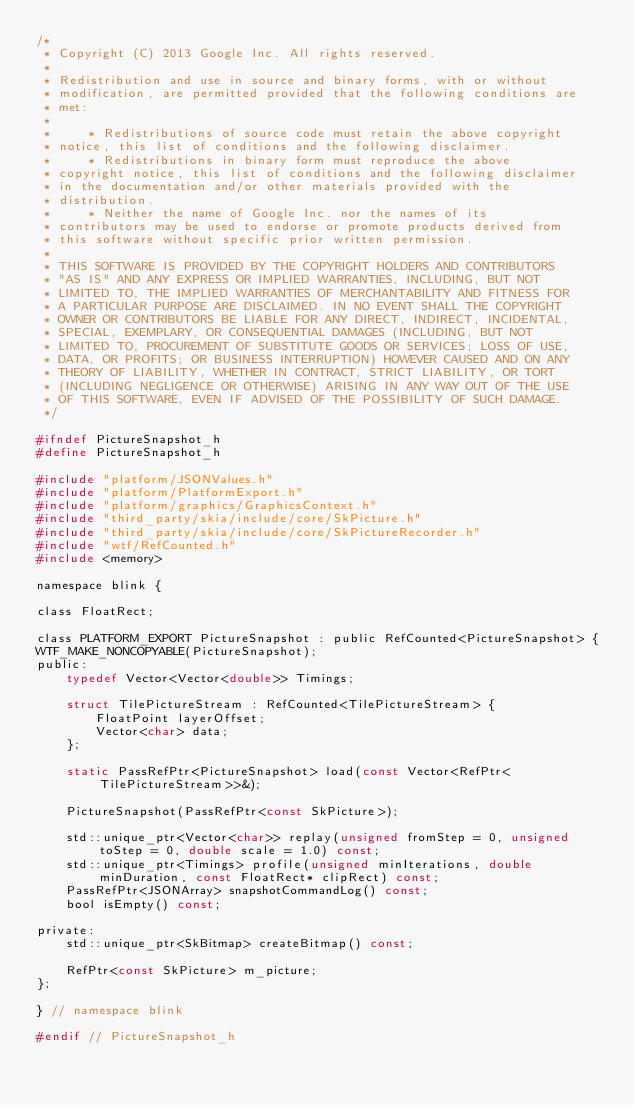Convert code to text. <code><loc_0><loc_0><loc_500><loc_500><_C_>/*
 * Copyright (C) 2013 Google Inc. All rights reserved.
 *
 * Redistribution and use in source and binary forms, with or without
 * modification, are permitted provided that the following conditions are
 * met:
 *
 *     * Redistributions of source code must retain the above copyright
 * notice, this list of conditions and the following disclaimer.
 *     * Redistributions in binary form must reproduce the above
 * copyright notice, this list of conditions and the following disclaimer
 * in the documentation and/or other materials provided with the
 * distribution.
 *     * Neither the name of Google Inc. nor the names of its
 * contributors may be used to endorse or promote products derived from
 * this software without specific prior written permission.
 *
 * THIS SOFTWARE IS PROVIDED BY THE COPYRIGHT HOLDERS AND CONTRIBUTORS
 * "AS IS" AND ANY EXPRESS OR IMPLIED WARRANTIES, INCLUDING, BUT NOT
 * LIMITED TO, THE IMPLIED WARRANTIES OF MERCHANTABILITY AND FITNESS FOR
 * A PARTICULAR PURPOSE ARE DISCLAIMED. IN NO EVENT SHALL THE COPYRIGHT
 * OWNER OR CONTRIBUTORS BE LIABLE FOR ANY DIRECT, INDIRECT, INCIDENTAL,
 * SPECIAL, EXEMPLARY, OR CONSEQUENTIAL DAMAGES (INCLUDING, BUT NOT
 * LIMITED TO, PROCUREMENT OF SUBSTITUTE GOODS OR SERVICES; LOSS OF USE,
 * DATA, OR PROFITS; OR BUSINESS INTERRUPTION) HOWEVER CAUSED AND ON ANY
 * THEORY OF LIABILITY, WHETHER IN CONTRACT, STRICT LIABILITY, OR TORT
 * (INCLUDING NEGLIGENCE OR OTHERWISE) ARISING IN ANY WAY OUT OF THE USE
 * OF THIS SOFTWARE, EVEN IF ADVISED OF THE POSSIBILITY OF SUCH DAMAGE.
 */

#ifndef PictureSnapshot_h
#define PictureSnapshot_h

#include "platform/JSONValues.h"
#include "platform/PlatformExport.h"
#include "platform/graphics/GraphicsContext.h"
#include "third_party/skia/include/core/SkPicture.h"
#include "third_party/skia/include/core/SkPictureRecorder.h"
#include "wtf/RefCounted.h"
#include <memory>

namespace blink {

class FloatRect;

class PLATFORM_EXPORT PictureSnapshot : public RefCounted<PictureSnapshot> {
WTF_MAKE_NONCOPYABLE(PictureSnapshot);
public:
    typedef Vector<Vector<double>> Timings;

    struct TilePictureStream : RefCounted<TilePictureStream> {
        FloatPoint layerOffset;
        Vector<char> data;
    };

    static PassRefPtr<PictureSnapshot> load(const Vector<RefPtr<TilePictureStream>>&);

    PictureSnapshot(PassRefPtr<const SkPicture>);

    std::unique_ptr<Vector<char>> replay(unsigned fromStep = 0, unsigned toStep = 0, double scale = 1.0) const;
    std::unique_ptr<Timings> profile(unsigned minIterations, double minDuration, const FloatRect* clipRect) const;
    PassRefPtr<JSONArray> snapshotCommandLog() const;
    bool isEmpty() const;

private:
    std::unique_ptr<SkBitmap> createBitmap() const;

    RefPtr<const SkPicture> m_picture;
};

} // namespace blink

#endif // PictureSnapshot_h
</code> 